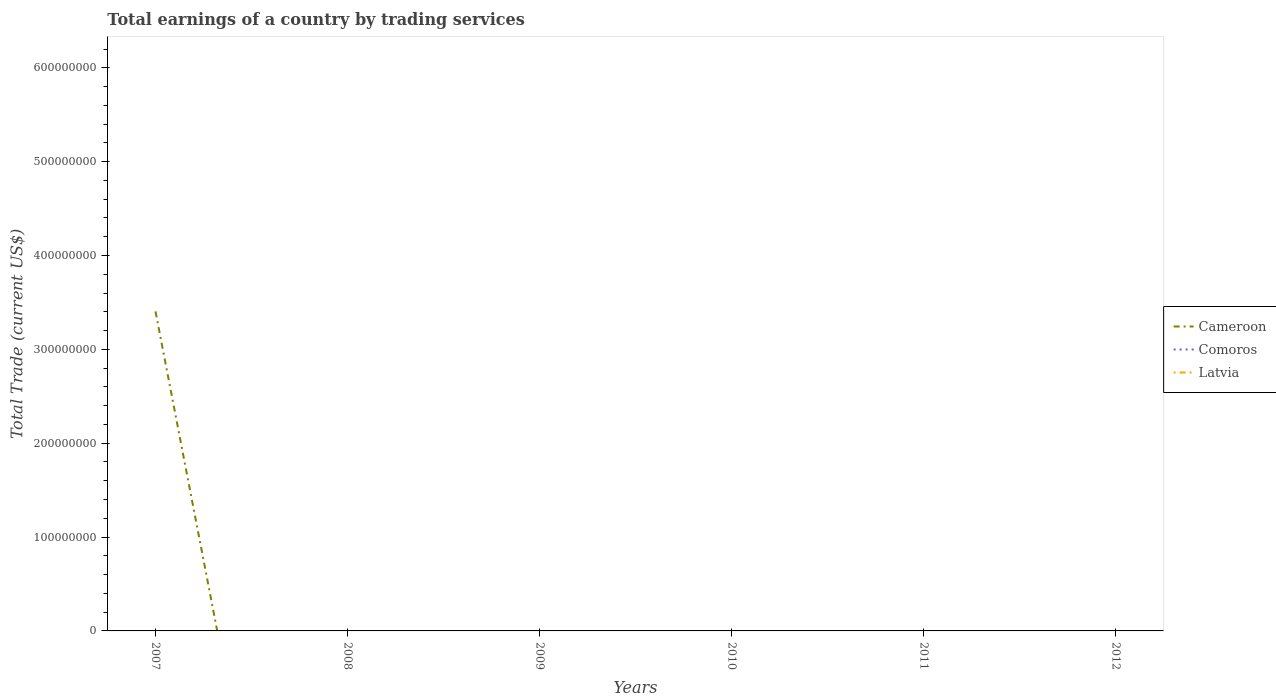Does the line corresponding to Comoros intersect with the line corresponding to Latvia?
Provide a succinct answer. Yes. Is the number of lines equal to the number of legend labels?
Ensure brevity in your answer.  No. What is the difference between the highest and the second highest total earnings in Cameroon?
Your response must be concise. 3.40e+08. Is the total earnings in Cameroon strictly greater than the total earnings in Latvia over the years?
Offer a terse response. No. How many lines are there?
Your response must be concise. 1. What is the difference between two consecutive major ticks on the Y-axis?
Your answer should be compact. 1.00e+08. Are the values on the major ticks of Y-axis written in scientific E-notation?
Offer a terse response. No. Does the graph contain any zero values?
Ensure brevity in your answer.  Yes. How many legend labels are there?
Your response must be concise. 3. What is the title of the graph?
Keep it short and to the point. Total earnings of a country by trading services. What is the label or title of the X-axis?
Make the answer very short. Years. What is the label or title of the Y-axis?
Your response must be concise. Total Trade (current US$). What is the Total Trade (current US$) of Cameroon in 2007?
Offer a very short reply. 3.40e+08. What is the Total Trade (current US$) of Comoros in 2008?
Provide a short and direct response. 0. What is the Total Trade (current US$) in Cameroon in 2009?
Offer a terse response. 0. What is the Total Trade (current US$) in Comoros in 2009?
Provide a succinct answer. 0. What is the Total Trade (current US$) in Cameroon in 2010?
Ensure brevity in your answer.  0. What is the Total Trade (current US$) in Cameroon in 2011?
Provide a short and direct response. 0. What is the Total Trade (current US$) in Comoros in 2011?
Your answer should be very brief. 0. What is the Total Trade (current US$) of Latvia in 2011?
Offer a very short reply. 0. Across all years, what is the maximum Total Trade (current US$) in Cameroon?
Make the answer very short. 3.40e+08. What is the total Total Trade (current US$) of Cameroon in the graph?
Provide a succinct answer. 3.40e+08. What is the total Total Trade (current US$) in Comoros in the graph?
Give a very brief answer. 0. What is the total Total Trade (current US$) in Latvia in the graph?
Keep it short and to the point. 0. What is the average Total Trade (current US$) of Cameroon per year?
Ensure brevity in your answer.  5.67e+07. What is the difference between the highest and the lowest Total Trade (current US$) of Cameroon?
Ensure brevity in your answer.  3.40e+08. 